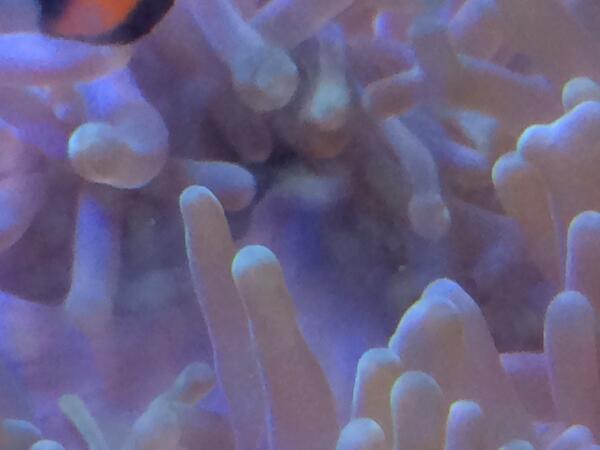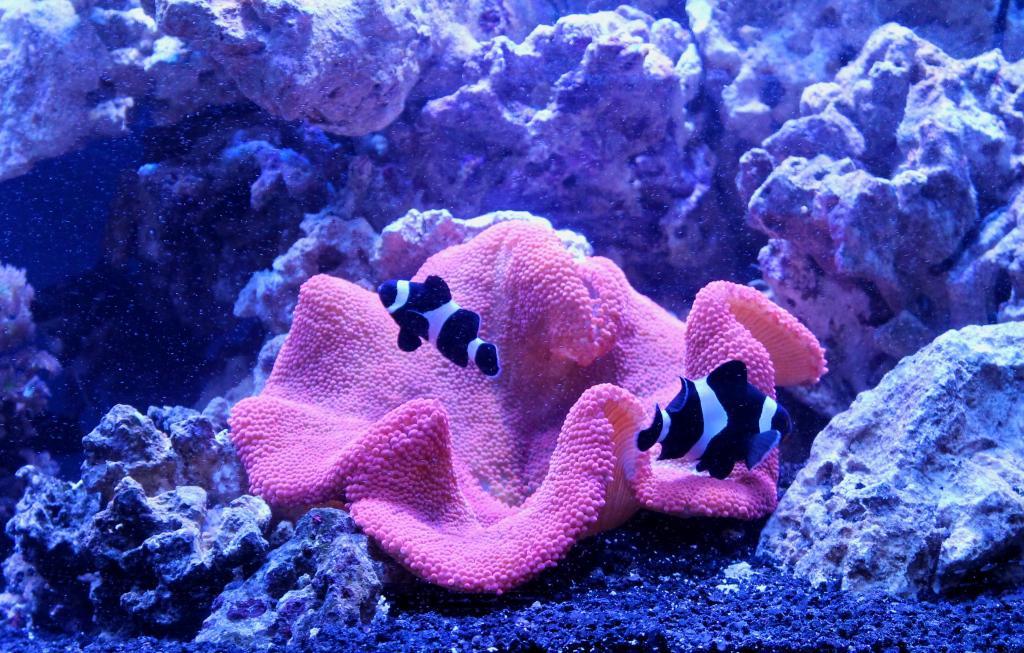The first image is the image on the left, the second image is the image on the right. For the images displayed, is the sentence "Right image shows a lavender anemone with plush-looking folds." factually correct? Answer yes or no. Yes. 